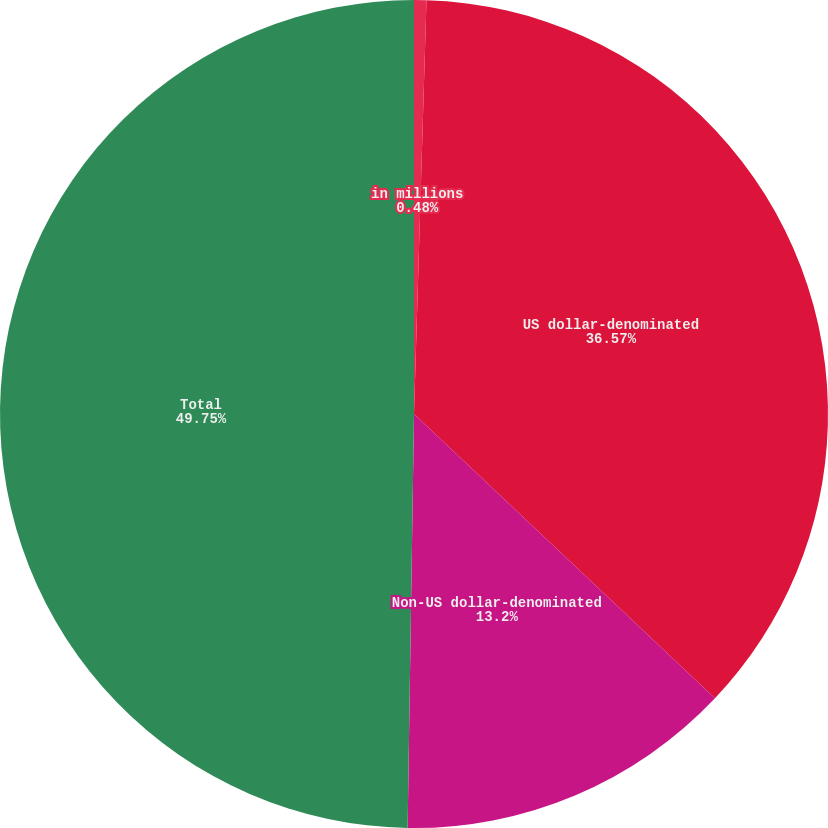Convert chart. <chart><loc_0><loc_0><loc_500><loc_500><pie_chart><fcel>in millions<fcel>US dollar-denominated<fcel>Non-US dollar-denominated<fcel>Total<nl><fcel>0.48%<fcel>36.57%<fcel>13.2%<fcel>49.76%<nl></chart> 